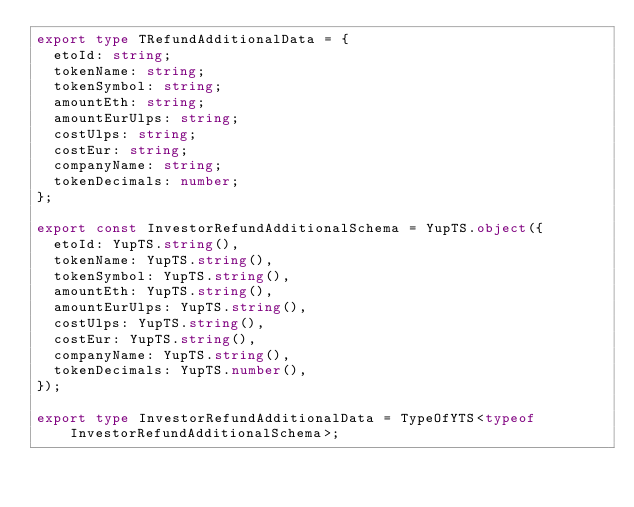<code> <loc_0><loc_0><loc_500><loc_500><_TypeScript_>export type TRefundAdditionalData = {
  etoId: string;
  tokenName: string;
  tokenSymbol: string;
  amountEth: string;
  amountEurUlps: string;
  costUlps: string;
  costEur: string;
  companyName: string;
  tokenDecimals: number;
};

export const InvestorRefundAdditionalSchema = YupTS.object({
  etoId: YupTS.string(),
  tokenName: YupTS.string(),
  tokenSymbol: YupTS.string(),
  amountEth: YupTS.string(),
  amountEurUlps: YupTS.string(),
  costUlps: YupTS.string(),
  costEur: YupTS.string(),
  companyName: YupTS.string(),
  tokenDecimals: YupTS.number(),
});

export type InvestorRefundAdditionalData = TypeOfYTS<typeof InvestorRefundAdditionalSchema>;
</code> 